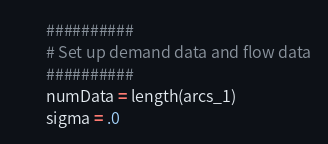<code> <loc_0><loc_0><loc_500><loc_500><_Julia_>	    ##########
	    # Set up demand data and flow data
	    ##########
	    numData = length(arcs_1)
	    sigma = .0</code> 